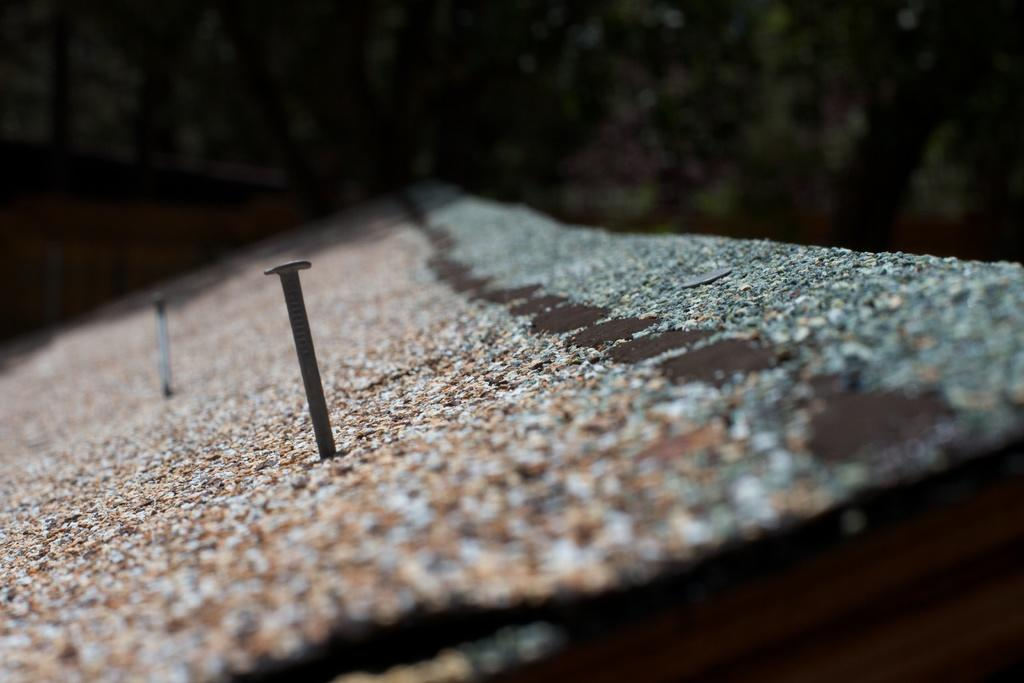What is present on the wall in the image? A nail is fixed to the wall in the image. Can you describe the background of the image? The background of the image appears blurred. How many hens are visible on the farm in the image? There is no farm or hen present in the image; it only features a wall with a nail and a blurred background. 